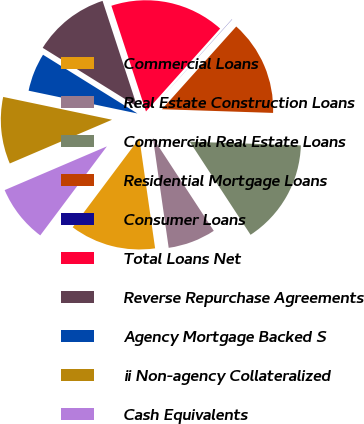Convert chart to OTSL. <chart><loc_0><loc_0><loc_500><loc_500><pie_chart><fcel>Commercial Loans<fcel>Real Estate Construction Loans<fcel>Commercial Real Estate Loans<fcel>Residential Mortgage Loans<fcel>Consumer Loans<fcel>Total Loans Net<fcel>Reverse Repurchase Agreements<fcel>Agency Mortgage Backed S<fcel>ii Non-agency Collateralized<fcel>Cash Equivalents<nl><fcel>12.49%<fcel>6.95%<fcel>15.26%<fcel>13.88%<fcel>0.03%<fcel>16.65%<fcel>11.11%<fcel>5.57%<fcel>9.72%<fcel>8.34%<nl></chart> 